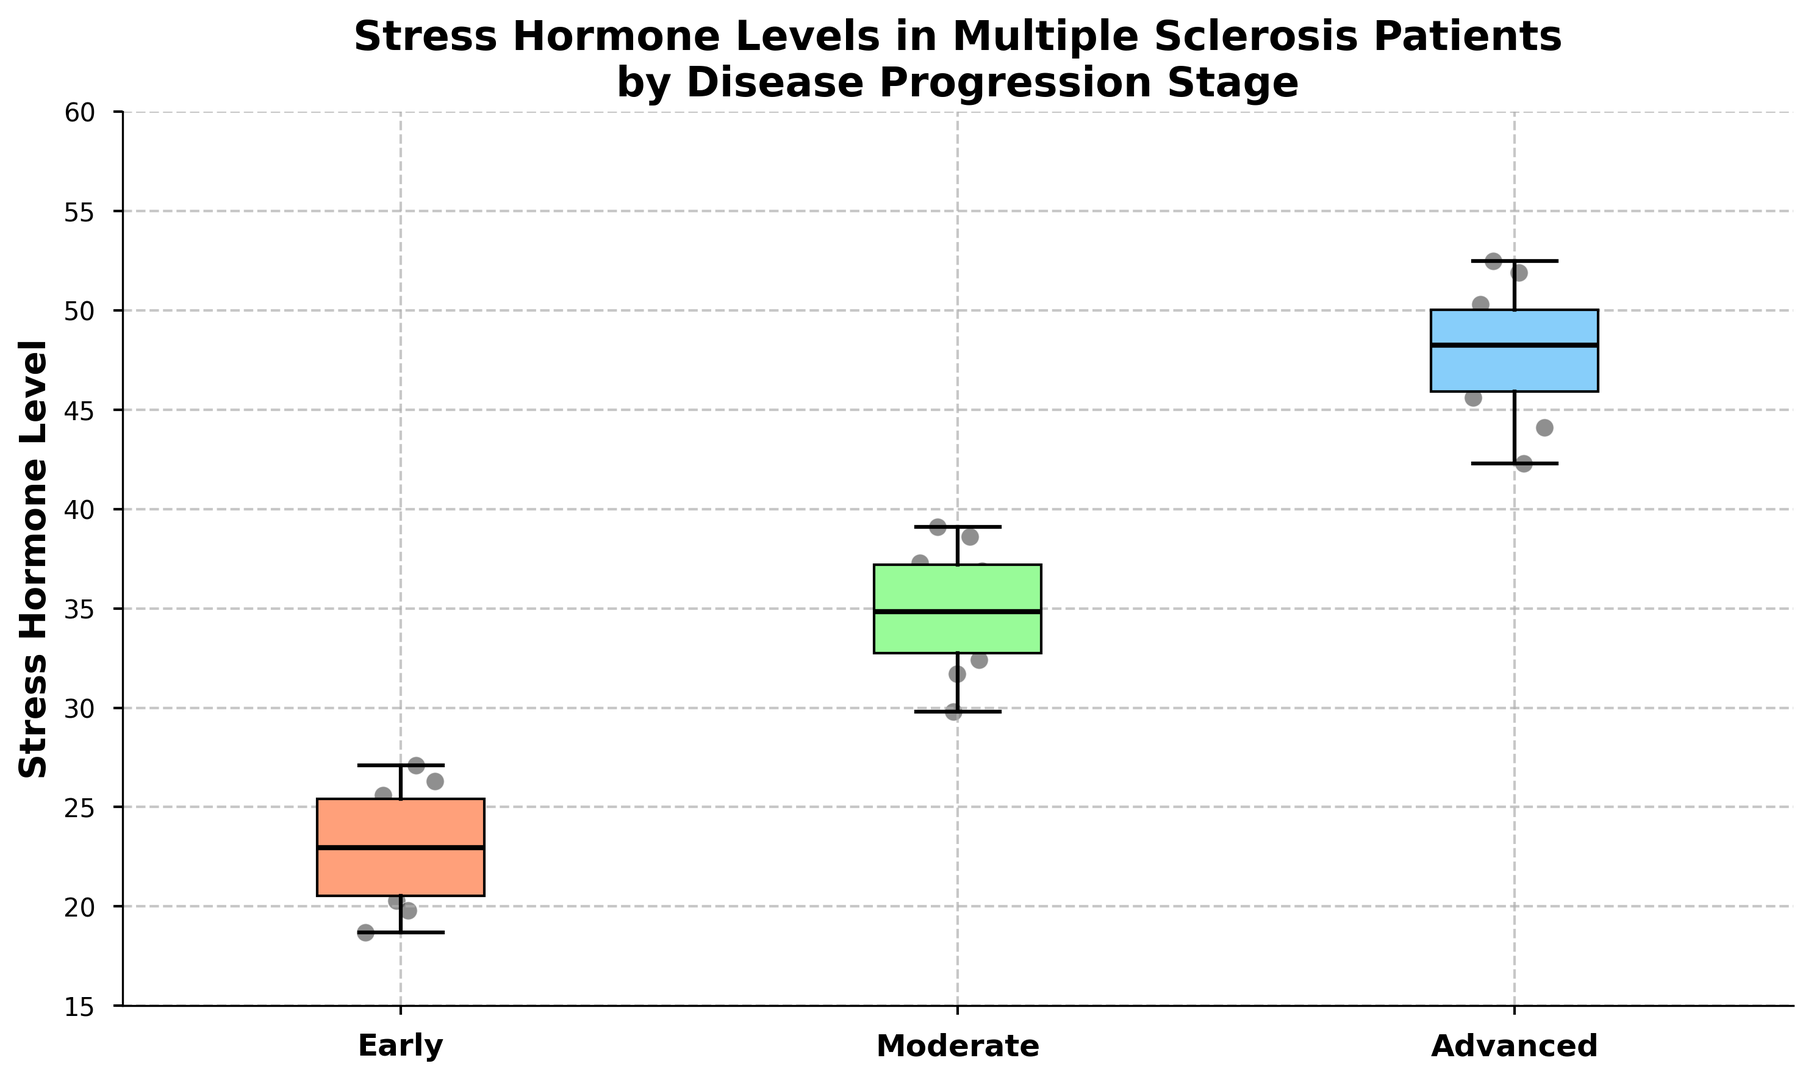Which disease stage has the highest median stress hormone level? The box plot shows the median values as thick black lines inside each box. The "Advanced" stage has the highest median level, followed by "Moderate" and then "Early".
Answer: Advanced Which stage shows the smallest interquartile range for stress hormone levels? The interquartile range is represented by the height of the boxes. Comparing the three stages, the "Moderate" stage has the smallest interquartile range.
Answer: Moderate What's the median stress hormone level for the Early stage? The thick black line inside the "Early" stage box represents the median. It is approximately at 23.5.
Answer: 23.5 Which stage exhibits the widest range of stress hormone levels (difference between maximum and minimum)? The range can be determined by looking at the vertical spread of the whiskers. The "Advanced" stage has the widest range.
Answer: Advanced Do any of the stages have overlapping interquartile ranges? By examining the boxes for overlap, it is clear that there is no overlapping between the interquartile ranges of the stages.
Answer: No What stage has the lowest observed stress hormone level? The lowest overall point in the box plot belongs to the "Early" stage, at approximately 18.7.
Answer: Early How does the median stress hormone level for the Moderate stage compare to the Early stage? The median for the "Moderate" stage is higher than the "Early" stage. By observing the thick black lines, it is clear the "Moderate" stage is around 35 while "Early" is around 23.5.
Answer: Moderate is higher What is the approximate interquartile range for the Advanced stage? The interquartile range is the height of the box. For the "Advanced" stage, it stretches from ~44 to ~50, making the IQR approximately 6 units.
Answer: 6 Is there a noticeable trend in stress hormone levels as the disease progresses? The figure shows a clear upward trend in stress hormone levels moving from "Early" to "Moderate" to "Advanced" stages.
Answer: Yes What is the highest stress hormone level observed in the plot, and to which stage does it belong? The highest point on the plot corresponds to the "Advanced" stage, at approximately 52.5.
Answer: 52.5, Advanced 